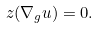<formula> <loc_0><loc_0><loc_500><loc_500>z ( \nabla _ { g } u ) = 0 .</formula> 